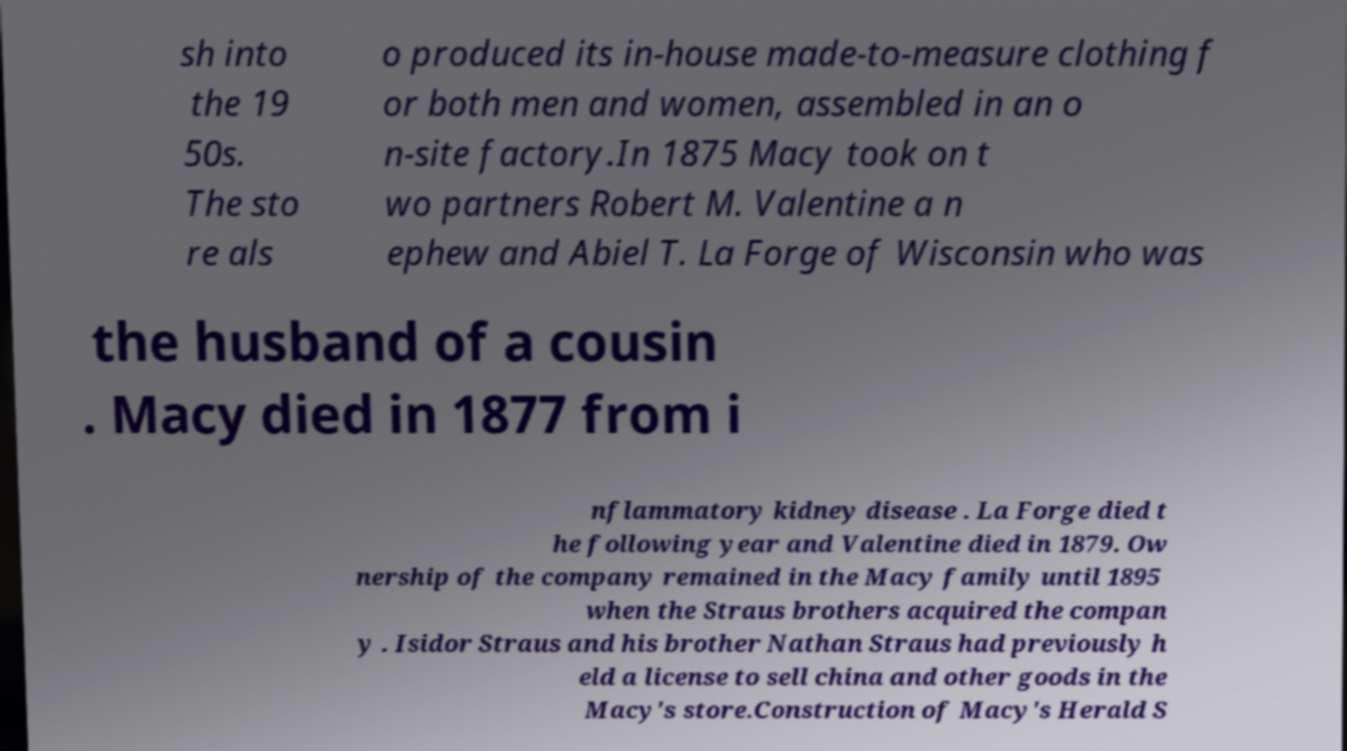Please identify and transcribe the text found in this image. sh into the 19 50s. The sto re als o produced its in-house made-to-measure clothing f or both men and women, assembled in an o n-site factory.In 1875 Macy took on t wo partners Robert M. Valentine a n ephew and Abiel T. La Forge of Wisconsin who was the husband of a cousin . Macy died in 1877 from i nflammatory kidney disease . La Forge died t he following year and Valentine died in 1879. Ow nership of the company remained in the Macy family until 1895 when the Straus brothers acquired the compan y . Isidor Straus and his brother Nathan Straus had previously h eld a license to sell china and other goods in the Macy's store.Construction of Macy's Herald S 